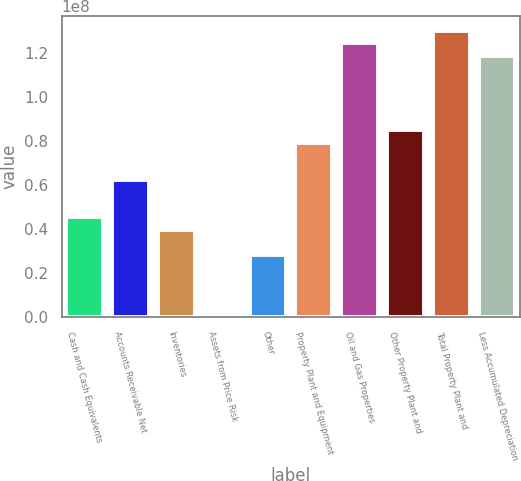Convert chart to OTSL. <chart><loc_0><loc_0><loc_500><loc_500><bar_chart><fcel>Cash and Cash Equivalents<fcel>Accounts Receivable Net<fcel>Inventories<fcel>Assets from Price Risk<fcel>Other<fcel>Property Plant and Equipment<fcel>Oil and Gas Properties<fcel>Other Property Plant and<fcel>Total Property Plant and<fcel>Less Accumulated Depreciation<nl><fcel>4.52147e+07<fcel>6.21674e+07<fcel>3.95639e+07<fcel>7699<fcel>2.82621e+07<fcel>7.912e+07<fcel>1.24327e+08<fcel>8.47709e+07<fcel>1.29978e+08<fcel>1.18676e+08<nl></chart> 